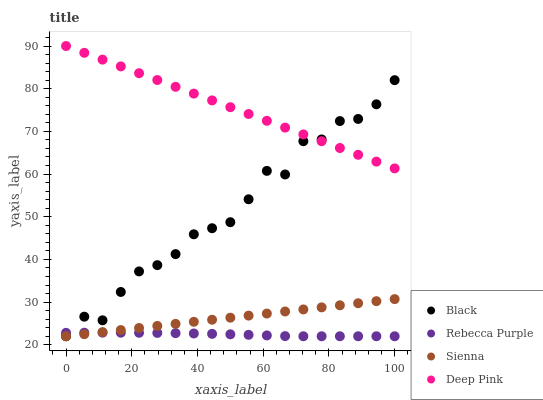Does Rebecca Purple have the minimum area under the curve?
Answer yes or no. Yes. Does Deep Pink have the maximum area under the curve?
Answer yes or no. Yes. Does Black have the minimum area under the curve?
Answer yes or no. No. Does Black have the maximum area under the curve?
Answer yes or no. No. Is Sienna the smoothest?
Answer yes or no. Yes. Is Black the roughest?
Answer yes or no. Yes. Is Deep Pink the smoothest?
Answer yes or no. No. Is Deep Pink the roughest?
Answer yes or no. No. Does Sienna have the lowest value?
Answer yes or no. Yes. Does Deep Pink have the lowest value?
Answer yes or no. No. Does Deep Pink have the highest value?
Answer yes or no. Yes. Does Black have the highest value?
Answer yes or no. No. Is Rebecca Purple less than Deep Pink?
Answer yes or no. Yes. Is Deep Pink greater than Sienna?
Answer yes or no. Yes. Does Rebecca Purple intersect Black?
Answer yes or no. Yes. Is Rebecca Purple less than Black?
Answer yes or no. No. Is Rebecca Purple greater than Black?
Answer yes or no. No. Does Rebecca Purple intersect Deep Pink?
Answer yes or no. No. 